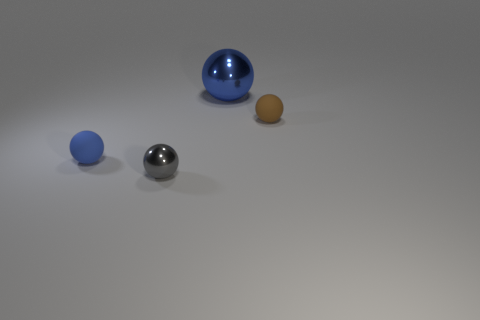Subtract 1 spheres. How many spheres are left? 3 Subtract all small brown spheres. How many spheres are left? 3 Subtract all gray balls. How many balls are left? 3 Add 4 small yellow things. How many objects exist? 8 Subtract all green spheres. Subtract all green cylinders. How many spheres are left? 4 Subtract 1 blue spheres. How many objects are left? 3 Subtract all small cyan matte cubes. Subtract all big blue balls. How many objects are left? 3 Add 2 gray metallic spheres. How many gray metallic spheres are left? 3 Add 3 red balls. How many red balls exist? 3 